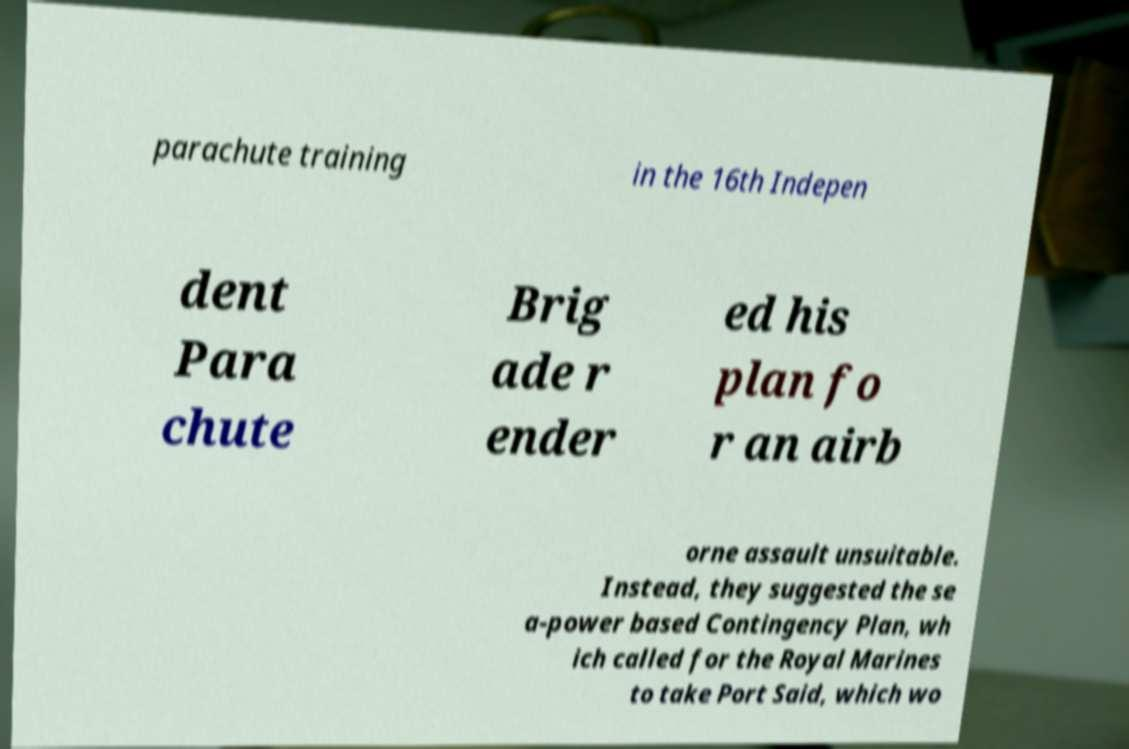Could you assist in decoding the text presented in this image and type it out clearly? parachute training in the 16th Indepen dent Para chute Brig ade r ender ed his plan fo r an airb orne assault unsuitable. Instead, they suggested the se a-power based Contingency Plan, wh ich called for the Royal Marines to take Port Said, which wo 